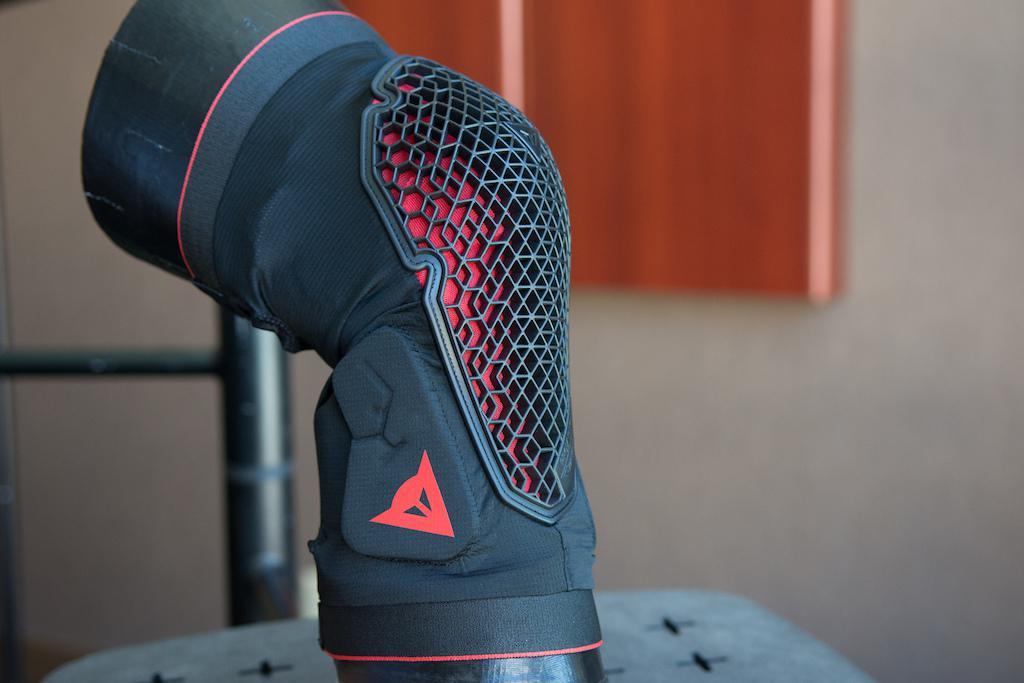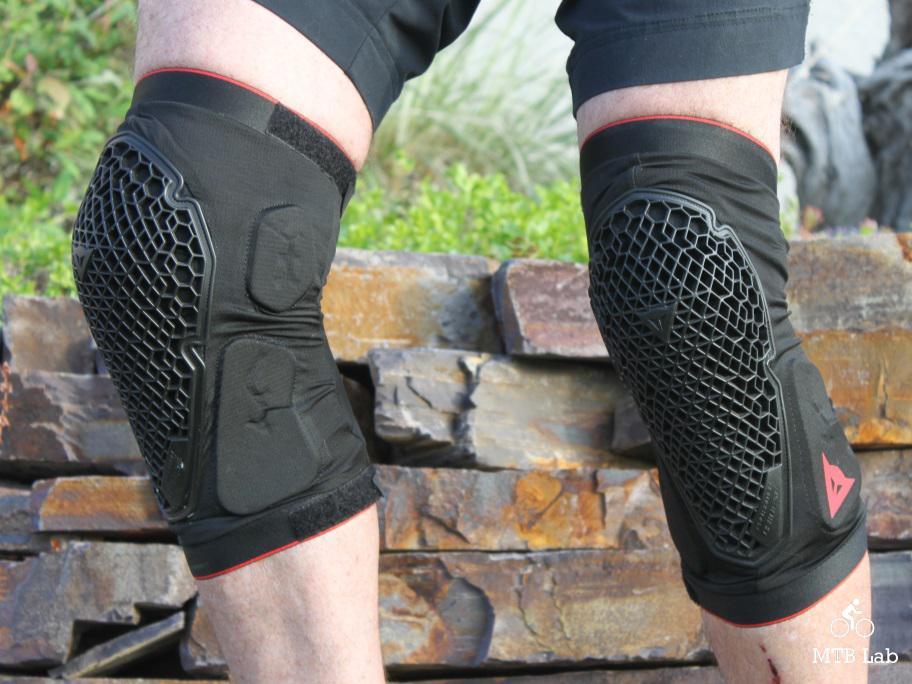The first image is the image on the left, the second image is the image on the right. Given the left and right images, does the statement "There is an elbow pad." hold true? Answer yes or no. No. The first image is the image on the left, the second image is the image on the right. Examine the images to the left and right. Is the description "Two legs in one image wear knee pads with a perforated front, and the other image shows a pad that is not on a person's knee." accurate? Answer yes or no. Yes. 